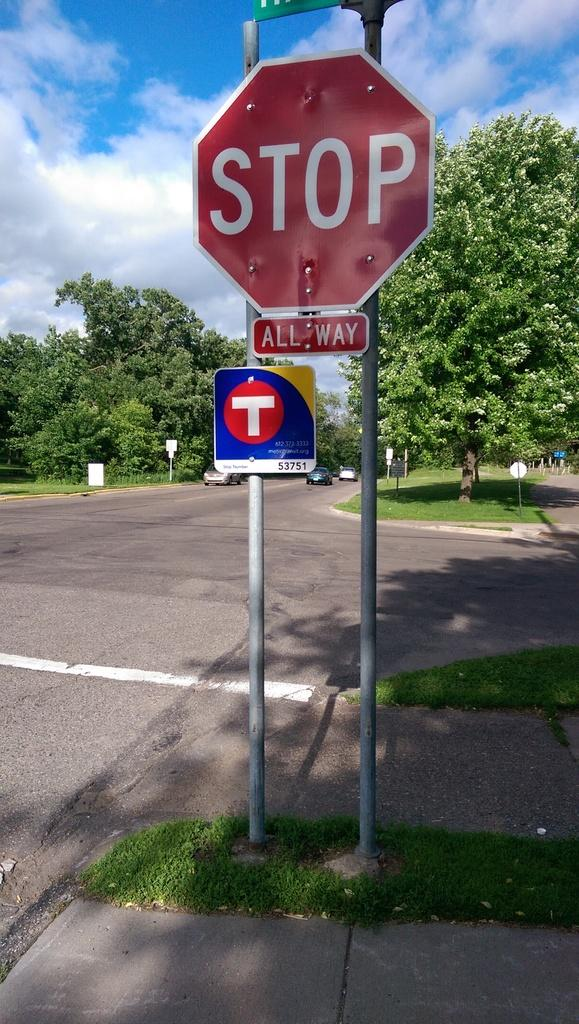<image>
Render a clear and concise summary of the photo. An all-way stop sign is attached to a pole above another sign with a "T" on it. 